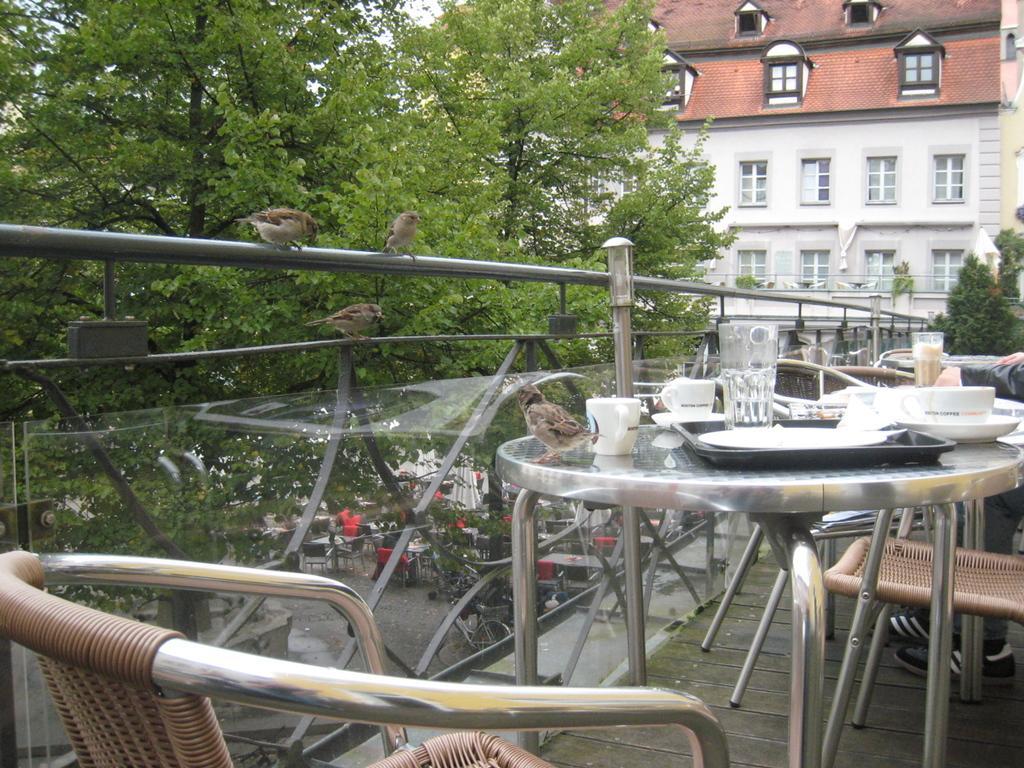In one or two sentences, can you explain what this image depicts? In this picture there is a table which has few cups,a bird and a glass on it and there are few chairs beside it and there is a fence in the left corner which has few birds on it and there are trees and a building in the background. 